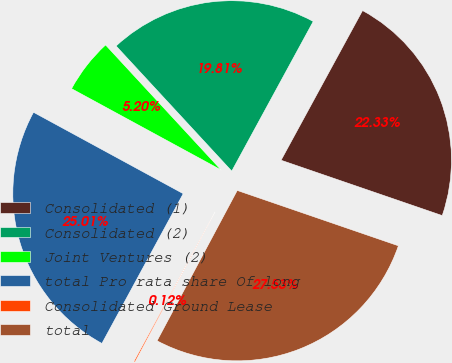Convert chart to OTSL. <chart><loc_0><loc_0><loc_500><loc_500><pie_chart><fcel>Consolidated (1)<fcel>Consolidated (2)<fcel>Joint Ventures (2)<fcel>total Pro rata share Of long<fcel>Consolidated Ground Lease<fcel>total<nl><fcel>22.33%<fcel>19.81%<fcel>5.2%<fcel>25.01%<fcel>0.12%<fcel>27.53%<nl></chart> 